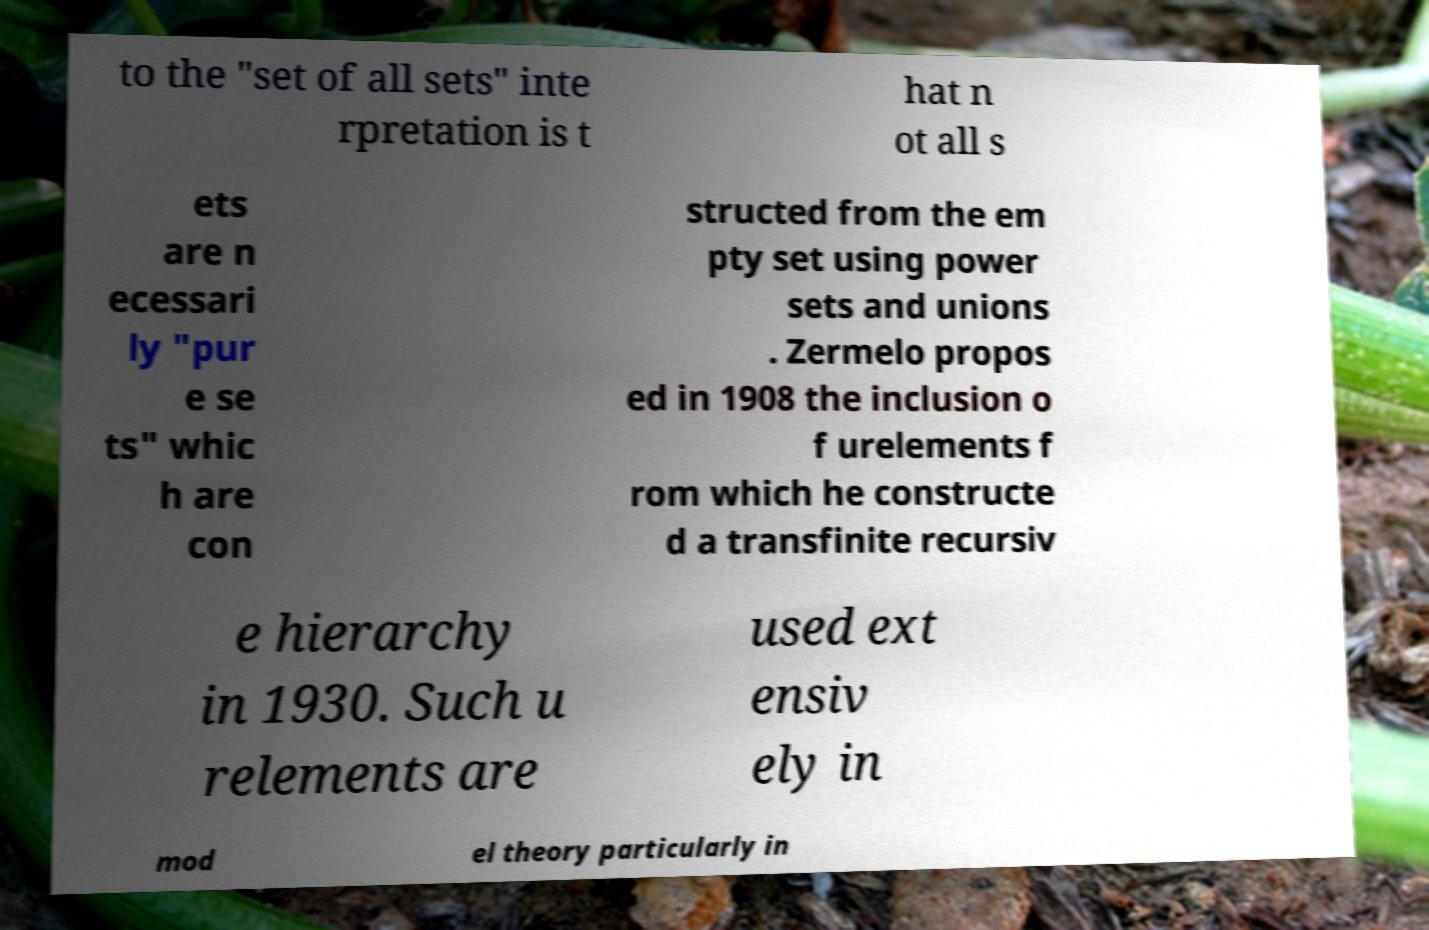Could you assist in decoding the text presented in this image and type it out clearly? to the "set of all sets" inte rpretation is t hat n ot all s ets are n ecessari ly "pur e se ts" whic h are con structed from the em pty set using power sets and unions . Zermelo propos ed in 1908 the inclusion o f urelements f rom which he constructe d a transfinite recursiv e hierarchy in 1930. Such u relements are used ext ensiv ely in mod el theory particularly in 